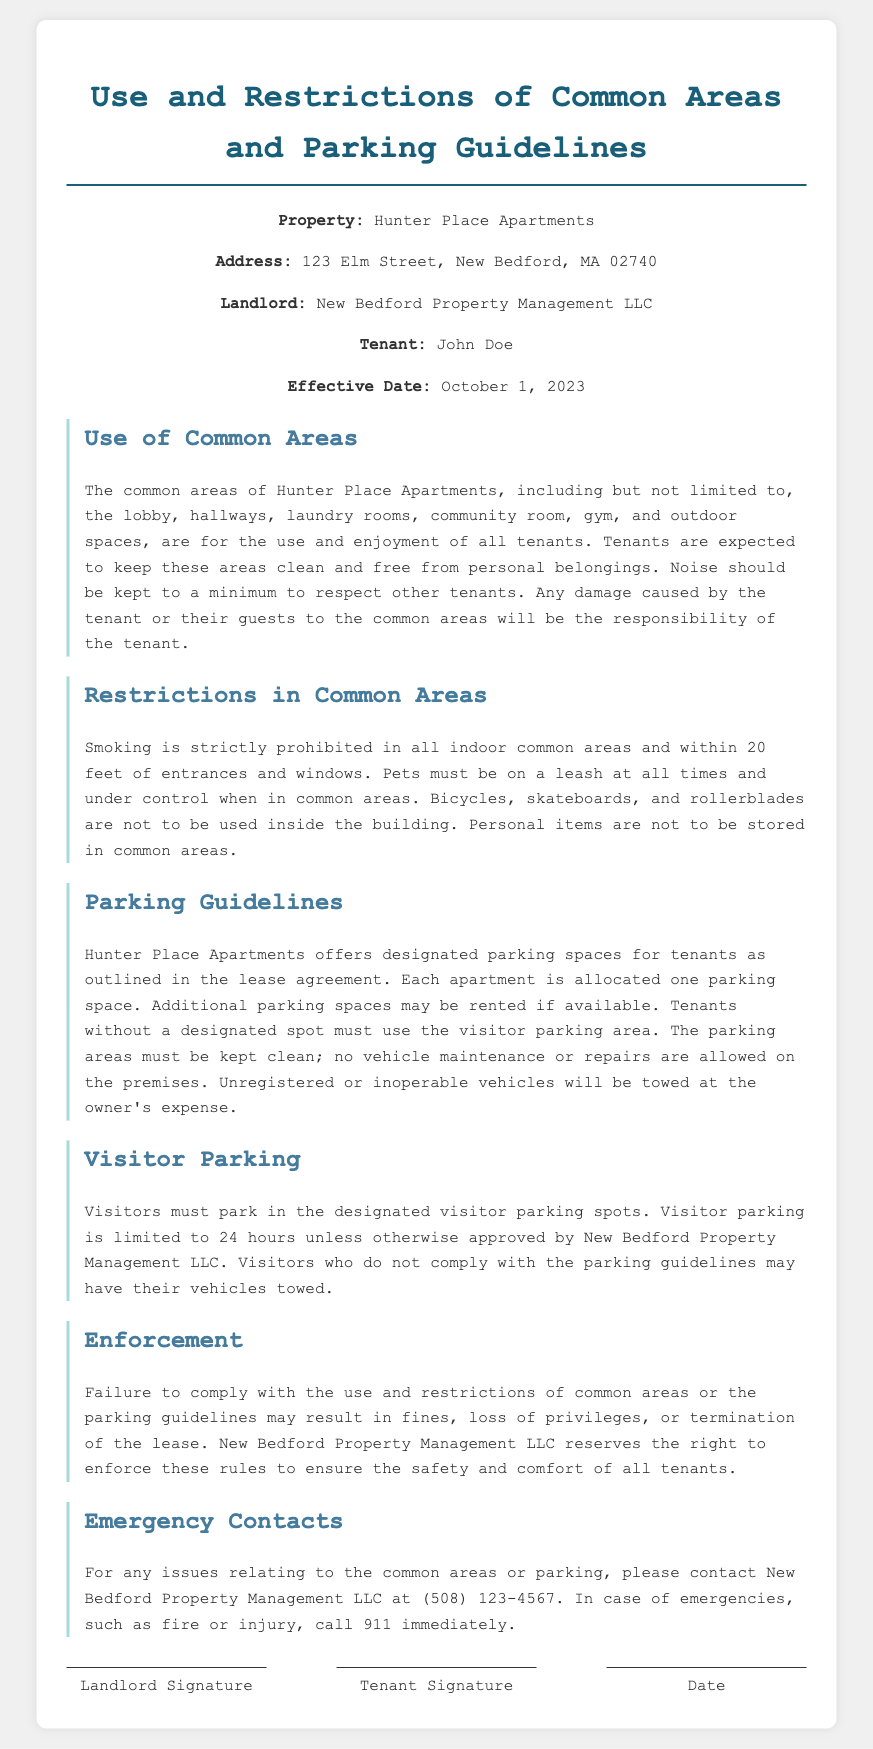What is the name of the property? The property is identified as Hunter Place Apartments.
Answer: Hunter Place Apartments What is the address of the property? The document specifies the address as 123 Elm Street, New Bedford, MA 02740.
Answer: 123 Elm Street, New Bedford, MA 02740 Who is the landlord? The landlord is mentioned as New Bedford Property Management LLC.
Answer: New Bedford Property Management LLC How many parking spaces are allocated per apartment? The lease states that each apartment is allocated one parking space.
Answer: One parking space What must visitors do to avoid towing? Visitors must park in the designated visitor parking spots per the guidelines to avoid towing.
Answer: Park in the designated visitor parking spots What is the consequence of unauthorized vehicle maintenance? Unauthorized vehicle maintenance or repairs are not allowed on the premises, leading to possible fines or towing as per the stated rules.
Answer: Towing What is the time limit for visitor parking without approval? The document mentions that visitor parking is limited to 24 hours unless otherwise approved.
Answer: 24 hours What is prohibited in indoor common areas? Smoking is strictly prohibited in all indoor common areas.
Answer: Smoking Who should be contacted in case of emergencies? The document instructs to call 911 immediately in case of emergencies.
Answer: Call 911 